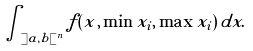<formula> <loc_0><loc_0><loc_500><loc_500>\int _ { ] a , b [ ^ { n } } f ( x , \min x _ { i } , \max x _ { i } ) \, d x .</formula> 